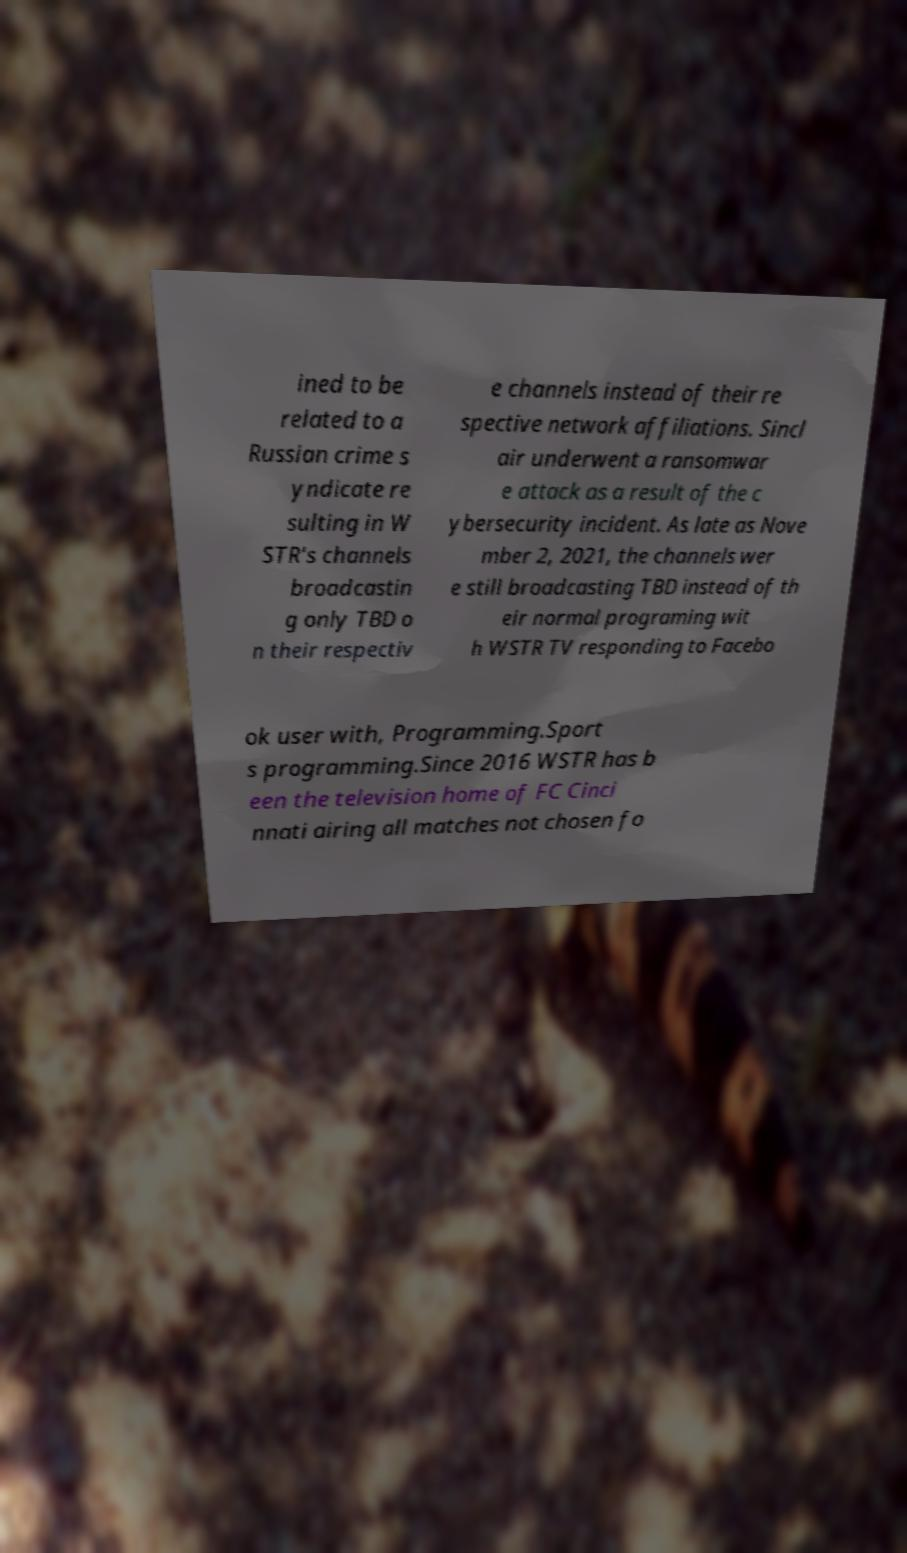For documentation purposes, I need the text within this image transcribed. Could you provide that? ined to be related to a Russian crime s yndicate re sulting in W STR's channels broadcastin g only TBD o n their respectiv e channels instead of their re spective network affiliations. Sincl air underwent a ransomwar e attack as a result of the c ybersecurity incident. As late as Nove mber 2, 2021, the channels wer e still broadcasting TBD instead of th eir normal programing wit h WSTR TV responding to Facebo ok user with, Programming.Sport s programming.Since 2016 WSTR has b een the television home of FC Cinci nnati airing all matches not chosen fo 